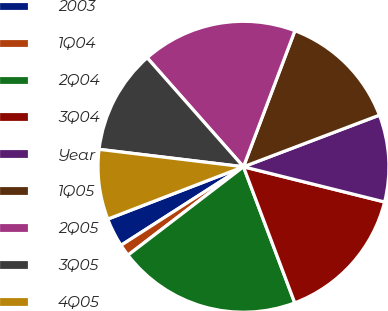<chart> <loc_0><loc_0><loc_500><loc_500><pie_chart><fcel>2003<fcel>1Q04<fcel>2Q04<fcel>3Q04<fcel>Year<fcel>1Q05<fcel>2Q05<fcel>3Q05<fcel>4Q05<nl><fcel>3.22%<fcel>1.32%<fcel>20.34%<fcel>15.37%<fcel>9.67%<fcel>13.47%<fcel>17.27%<fcel>11.57%<fcel>7.77%<nl></chart> 